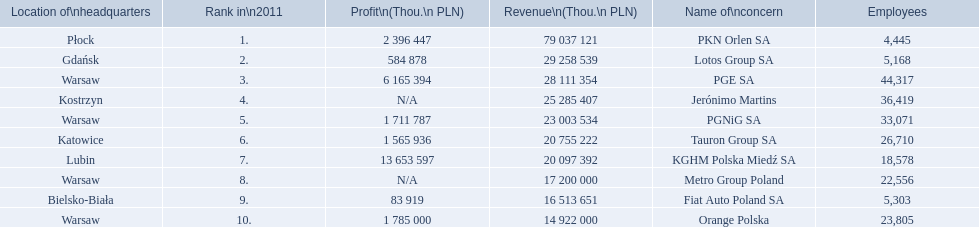What company has 28 111 354 thou.in revenue? PGE SA. What revenue does lotus group sa have? 29 258 539. Who has the next highest revenue than lotus group sa? PKN Orlen SA. 